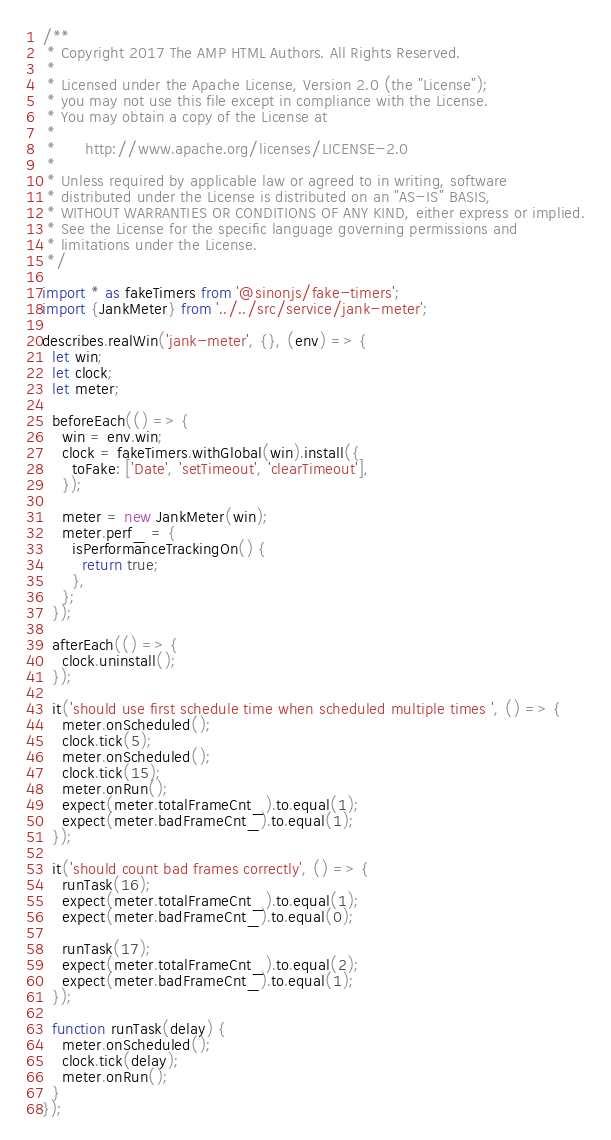Convert code to text. <code><loc_0><loc_0><loc_500><loc_500><_JavaScript_>/**
 * Copyright 2017 The AMP HTML Authors. All Rights Reserved.
 *
 * Licensed under the Apache License, Version 2.0 (the "License");
 * you may not use this file except in compliance with the License.
 * You may obtain a copy of the License at
 *
 *      http://www.apache.org/licenses/LICENSE-2.0
 *
 * Unless required by applicable law or agreed to in writing, software
 * distributed under the License is distributed on an "AS-IS" BASIS,
 * WITHOUT WARRANTIES OR CONDITIONS OF ANY KIND, either express or implied.
 * See the License for the specific language governing permissions and
 * limitations under the License.
 */

import * as fakeTimers from '@sinonjs/fake-timers';
import {JankMeter} from '../../src/service/jank-meter';

describes.realWin('jank-meter', {}, (env) => {
  let win;
  let clock;
  let meter;

  beforeEach(() => {
    win = env.win;
    clock = fakeTimers.withGlobal(win).install({
      toFake: ['Date', 'setTimeout', 'clearTimeout'],
    });

    meter = new JankMeter(win);
    meter.perf_ = {
      isPerformanceTrackingOn() {
        return true;
      },
    };
  });

  afterEach(() => {
    clock.uninstall();
  });

  it('should use first schedule time when scheduled multiple times ', () => {
    meter.onScheduled();
    clock.tick(5);
    meter.onScheduled();
    clock.tick(15);
    meter.onRun();
    expect(meter.totalFrameCnt_).to.equal(1);
    expect(meter.badFrameCnt_).to.equal(1);
  });

  it('should count bad frames correctly', () => {
    runTask(16);
    expect(meter.totalFrameCnt_).to.equal(1);
    expect(meter.badFrameCnt_).to.equal(0);

    runTask(17);
    expect(meter.totalFrameCnt_).to.equal(2);
    expect(meter.badFrameCnt_).to.equal(1);
  });

  function runTask(delay) {
    meter.onScheduled();
    clock.tick(delay);
    meter.onRun();
  }
});
</code> 